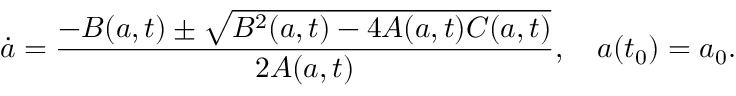Convert formula to latex. <formula><loc_0><loc_0><loc_500><loc_500>\dot { a } = \frac { - B ( a , t ) \pm \sqrt { B ^ { 2 } ( a , t ) - 4 A ( a , t ) C ( a , t ) } } { 2 A ( a , t ) } , \quad a ( t _ { 0 } ) = a _ { 0 } .</formula> 